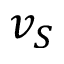Convert formula to latex. <formula><loc_0><loc_0><loc_500><loc_500>v _ { S }</formula> 